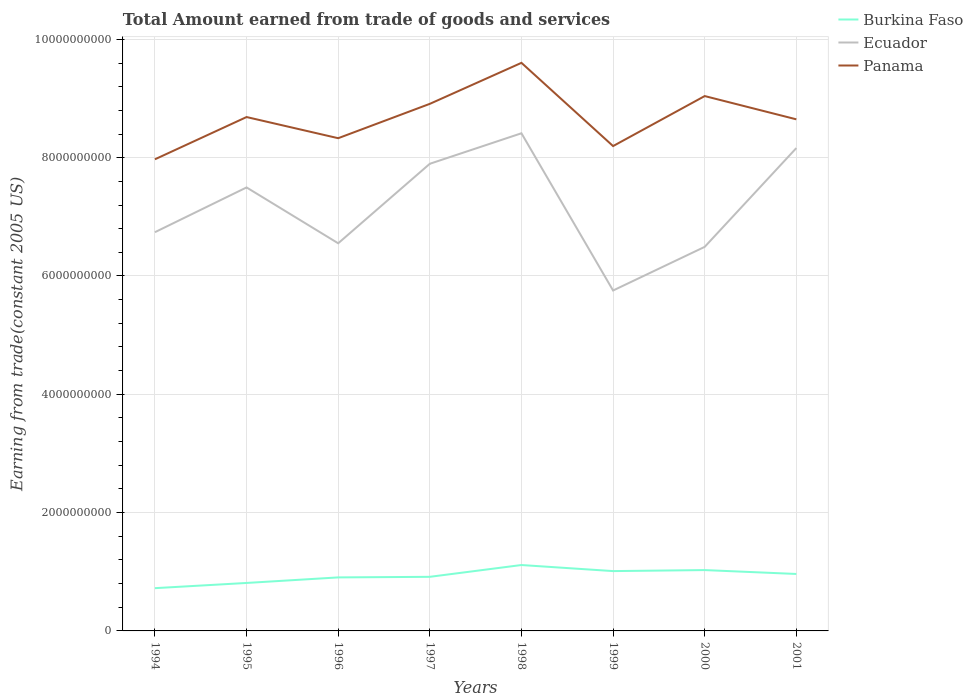Does the line corresponding to Ecuador intersect with the line corresponding to Burkina Faso?
Offer a very short reply. No. Across all years, what is the maximum total amount earned by trading goods and services in Burkina Faso?
Provide a short and direct response. 7.23e+08. In which year was the total amount earned by trading goods and services in Burkina Faso maximum?
Provide a short and direct response. 1994. What is the total total amount earned by trading goods and services in Panama in the graph?
Make the answer very short. -3.55e+08. What is the difference between the highest and the second highest total amount earned by trading goods and services in Ecuador?
Ensure brevity in your answer.  2.66e+09. How many years are there in the graph?
Your answer should be very brief. 8. What is the difference between two consecutive major ticks on the Y-axis?
Your answer should be compact. 2.00e+09. Are the values on the major ticks of Y-axis written in scientific E-notation?
Give a very brief answer. No. Does the graph contain any zero values?
Offer a terse response. No. Where does the legend appear in the graph?
Give a very brief answer. Top right. What is the title of the graph?
Your response must be concise. Total Amount earned from trade of goods and services. What is the label or title of the Y-axis?
Offer a terse response. Earning from trade(constant 2005 US). What is the Earning from trade(constant 2005 US) of Burkina Faso in 1994?
Your response must be concise. 7.23e+08. What is the Earning from trade(constant 2005 US) in Ecuador in 1994?
Your response must be concise. 6.74e+09. What is the Earning from trade(constant 2005 US) of Panama in 1994?
Your answer should be very brief. 7.97e+09. What is the Earning from trade(constant 2005 US) of Burkina Faso in 1995?
Provide a short and direct response. 8.11e+08. What is the Earning from trade(constant 2005 US) of Ecuador in 1995?
Give a very brief answer. 7.50e+09. What is the Earning from trade(constant 2005 US) in Panama in 1995?
Your response must be concise. 8.69e+09. What is the Earning from trade(constant 2005 US) of Burkina Faso in 1996?
Provide a short and direct response. 9.05e+08. What is the Earning from trade(constant 2005 US) of Ecuador in 1996?
Provide a succinct answer. 6.55e+09. What is the Earning from trade(constant 2005 US) in Panama in 1996?
Your response must be concise. 8.33e+09. What is the Earning from trade(constant 2005 US) of Burkina Faso in 1997?
Offer a very short reply. 9.15e+08. What is the Earning from trade(constant 2005 US) of Ecuador in 1997?
Keep it short and to the point. 7.90e+09. What is the Earning from trade(constant 2005 US) in Panama in 1997?
Provide a short and direct response. 8.91e+09. What is the Earning from trade(constant 2005 US) of Burkina Faso in 1998?
Your response must be concise. 1.11e+09. What is the Earning from trade(constant 2005 US) in Ecuador in 1998?
Your response must be concise. 8.41e+09. What is the Earning from trade(constant 2005 US) of Panama in 1998?
Your response must be concise. 9.60e+09. What is the Earning from trade(constant 2005 US) in Burkina Faso in 1999?
Make the answer very short. 1.01e+09. What is the Earning from trade(constant 2005 US) of Ecuador in 1999?
Keep it short and to the point. 5.75e+09. What is the Earning from trade(constant 2005 US) in Panama in 1999?
Your response must be concise. 8.20e+09. What is the Earning from trade(constant 2005 US) of Burkina Faso in 2000?
Offer a very short reply. 1.03e+09. What is the Earning from trade(constant 2005 US) in Ecuador in 2000?
Provide a succinct answer. 6.49e+09. What is the Earning from trade(constant 2005 US) in Panama in 2000?
Your answer should be very brief. 9.04e+09. What is the Earning from trade(constant 2005 US) of Burkina Faso in 2001?
Offer a terse response. 9.63e+08. What is the Earning from trade(constant 2005 US) of Ecuador in 2001?
Your response must be concise. 8.16e+09. What is the Earning from trade(constant 2005 US) of Panama in 2001?
Provide a succinct answer. 8.65e+09. Across all years, what is the maximum Earning from trade(constant 2005 US) in Burkina Faso?
Your response must be concise. 1.11e+09. Across all years, what is the maximum Earning from trade(constant 2005 US) in Ecuador?
Keep it short and to the point. 8.41e+09. Across all years, what is the maximum Earning from trade(constant 2005 US) of Panama?
Your response must be concise. 9.60e+09. Across all years, what is the minimum Earning from trade(constant 2005 US) in Burkina Faso?
Offer a very short reply. 7.23e+08. Across all years, what is the minimum Earning from trade(constant 2005 US) in Ecuador?
Offer a terse response. 5.75e+09. Across all years, what is the minimum Earning from trade(constant 2005 US) of Panama?
Give a very brief answer. 7.97e+09. What is the total Earning from trade(constant 2005 US) of Burkina Faso in the graph?
Make the answer very short. 7.47e+09. What is the total Earning from trade(constant 2005 US) of Ecuador in the graph?
Ensure brevity in your answer.  5.75e+1. What is the total Earning from trade(constant 2005 US) of Panama in the graph?
Your response must be concise. 6.94e+1. What is the difference between the Earning from trade(constant 2005 US) in Burkina Faso in 1994 and that in 1995?
Offer a terse response. -8.80e+07. What is the difference between the Earning from trade(constant 2005 US) in Ecuador in 1994 and that in 1995?
Make the answer very short. -7.57e+08. What is the difference between the Earning from trade(constant 2005 US) of Panama in 1994 and that in 1995?
Ensure brevity in your answer.  -7.14e+08. What is the difference between the Earning from trade(constant 2005 US) of Burkina Faso in 1994 and that in 1996?
Offer a very short reply. -1.82e+08. What is the difference between the Earning from trade(constant 2005 US) of Ecuador in 1994 and that in 1996?
Keep it short and to the point. 1.87e+08. What is the difference between the Earning from trade(constant 2005 US) of Panama in 1994 and that in 1996?
Make the answer very short. -3.57e+08. What is the difference between the Earning from trade(constant 2005 US) of Burkina Faso in 1994 and that in 1997?
Ensure brevity in your answer.  -1.92e+08. What is the difference between the Earning from trade(constant 2005 US) in Ecuador in 1994 and that in 1997?
Your response must be concise. -1.16e+09. What is the difference between the Earning from trade(constant 2005 US) in Panama in 1994 and that in 1997?
Your answer should be compact. -9.37e+08. What is the difference between the Earning from trade(constant 2005 US) in Burkina Faso in 1994 and that in 1998?
Make the answer very short. -3.91e+08. What is the difference between the Earning from trade(constant 2005 US) in Ecuador in 1994 and that in 1998?
Offer a very short reply. -1.67e+09. What is the difference between the Earning from trade(constant 2005 US) of Panama in 1994 and that in 1998?
Your answer should be very brief. -1.63e+09. What is the difference between the Earning from trade(constant 2005 US) in Burkina Faso in 1994 and that in 1999?
Offer a terse response. -2.88e+08. What is the difference between the Earning from trade(constant 2005 US) in Ecuador in 1994 and that in 1999?
Provide a short and direct response. 9.86e+08. What is the difference between the Earning from trade(constant 2005 US) of Panama in 1994 and that in 1999?
Your answer should be compact. -2.24e+08. What is the difference between the Earning from trade(constant 2005 US) in Burkina Faso in 1994 and that in 2000?
Ensure brevity in your answer.  -3.06e+08. What is the difference between the Earning from trade(constant 2005 US) of Ecuador in 1994 and that in 2000?
Your answer should be compact. 2.48e+08. What is the difference between the Earning from trade(constant 2005 US) of Panama in 1994 and that in 2000?
Make the answer very short. -1.07e+09. What is the difference between the Earning from trade(constant 2005 US) of Burkina Faso in 1994 and that in 2001?
Provide a short and direct response. -2.40e+08. What is the difference between the Earning from trade(constant 2005 US) in Ecuador in 1994 and that in 2001?
Keep it short and to the point. -1.42e+09. What is the difference between the Earning from trade(constant 2005 US) of Panama in 1994 and that in 2001?
Provide a short and direct response. -6.76e+08. What is the difference between the Earning from trade(constant 2005 US) in Burkina Faso in 1995 and that in 1996?
Give a very brief answer. -9.37e+07. What is the difference between the Earning from trade(constant 2005 US) of Ecuador in 1995 and that in 1996?
Give a very brief answer. 9.44e+08. What is the difference between the Earning from trade(constant 2005 US) in Panama in 1995 and that in 1996?
Your answer should be very brief. 3.58e+08. What is the difference between the Earning from trade(constant 2005 US) in Burkina Faso in 1995 and that in 1997?
Make the answer very short. -1.04e+08. What is the difference between the Earning from trade(constant 2005 US) of Ecuador in 1995 and that in 1997?
Provide a short and direct response. -4.00e+08. What is the difference between the Earning from trade(constant 2005 US) of Panama in 1995 and that in 1997?
Your answer should be very brief. -2.23e+08. What is the difference between the Earning from trade(constant 2005 US) of Burkina Faso in 1995 and that in 1998?
Ensure brevity in your answer.  -3.03e+08. What is the difference between the Earning from trade(constant 2005 US) of Ecuador in 1995 and that in 1998?
Your answer should be compact. -9.16e+08. What is the difference between the Earning from trade(constant 2005 US) of Panama in 1995 and that in 1998?
Your answer should be very brief. -9.16e+08. What is the difference between the Earning from trade(constant 2005 US) of Burkina Faso in 1995 and that in 1999?
Your answer should be compact. -2.00e+08. What is the difference between the Earning from trade(constant 2005 US) of Ecuador in 1995 and that in 1999?
Your response must be concise. 1.74e+09. What is the difference between the Earning from trade(constant 2005 US) of Panama in 1995 and that in 1999?
Offer a terse response. 4.91e+08. What is the difference between the Earning from trade(constant 2005 US) of Burkina Faso in 1995 and that in 2000?
Offer a very short reply. -2.18e+08. What is the difference between the Earning from trade(constant 2005 US) in Ecuador in 1995 and that in 2000?
Give a very brief answer. 1.00e+09. What is the difference between the Earning from trade(constant 2005 US) in Panama in 1995 and that in 2000?
Keep it short and to the point. -3.55e+08. What is the difference between the Earning from trade(constant 2005 US) in Burkina Faso in 1995 and that in 2001?
Keep it short and to the point. -1.52e+08. What is the difference between the Earning from trade(constant 2005 US) of Ecuador in 1995 and that in 2001?
Your answer should be very brief. -6.65e+08. What is the difference between the Earning from trade(constant 2005 US) of Panama in 1995 and that in 2001?
Your response must be concise. 3.86e+07. What is the difference between the Earning from trade(constant 2005 US) of Burkina Faso in 1996 and that in 1997?
Ensure brevity in your answer.  -9.90e+06. What is the difference between the Earning from trade(constant 2005 US) in Ecuador in 1996 and that in 1997?
Offer a very short reply. -1.34e+09. What is the difference between the Earning from trade(constant 2005 US) in Panama in 1996 and that in 1997?
Ensure brevity in your answer.  -5.81e+08. What is the difference between the Earning from trade(constant 2005 US) of Burkina Faso in 1996 and that in 1998?
Make the answer very short. -2.09e+08. What is the difference between the Earning from trade(constant 2005 US) of Ecuador in 1996 and that in 1998?
Offer a very short reply. -1.86e+09. What is the difference between the Earning from trade(constant 2005 US) in Panama in 1996 and that in 1998?
Keep it short and to the point. -1.27e+09. What is the difference between the Earning from trade(constant 2005 US) of Burkina Faso in 1996 and that in 1999?
Make the answer very short. -1.07e+08. What is the difference between the Earning from trade(constant 2005 US) in Ecuador in 1996 and that in 1999?
Ensure brevity in your answer.  7.98e+08. What is the difference between the Earning from trade(constant 2005 US) of Panama in 1996 and that in 1999?
Ensure brevity in your answer.  1.33e+08. What is the difference between the Earning from trade(constant 2005 US) of Burkina Faso in 1996 and that in 2000?
Your response must be concise. -1.24e+08. What is the difference between the Earning from trade(constant 2005 US) in Ecuador in 1996 and that in 2000?
Offer a very short reply. 6.02e+07. What is the difference between the Earning from trade(constant 2005 US) of Panama in 1996 and that in 2000?
Provide a succinct answer. -7.12e+08. What is the difference between the Earning from trade(constant 2005 US) of Burkina Faso in 1996 and that in 2001?
Provide a short and direct response. -5.82e+07. What is the difference between the Earning from trade(constant 2005 US) of Ecuador in 1996 and that in 2001?
Offer a terse response. -1.61e+09. What is the difference between the Earning from trade(constant 2005 US) of Panama in 1996 and that in 2001?
Offer a very short reply. -3.19e+08. What is the difference between the Earning from trade(constant 2005 US) in Burkina Faso in 1997 and that in 1998?
Offer a very short reply. -1.99e+08. What is the difference between the Earning from trade(constant 2005 US) of Ecuador in 1997 and that in 1998?
Your response must be concise. -5.16e+08. What is the difference between the Earning from trade(constant 2005 US) in Panama in 1997 and that in 1998?
Provide a succinct answer. -6.93e+08. What is the difference between the Earning from trade(constant 2005 US) of Burkina Faso in 1997 and that in 1999?
Offer a terse response. -9.68e+07. What is the difference between the Earning from trade(constant 2005 US) of Ecuador in 1997 and that in 1999?
Give a very brief answer. 2.14e+09. What is the difference between the Earning from trade(constant 2005 US) in Panama in 1997 and that in 1999?
Offer a terse response. 7.14e+08. What is the difference between the Earning from trade(constant 2005 US) in Burkina Faso in 1997 and that in 2000?
Give a very brief answer. -1.14e+08. What is the difference between the Earning from trade(constant 2005 US) of Ecuador in 1997 and that in 2000?
Your response must be concise. 1.40e+09. What is the difference between the Earning from trade(constant 2005 US) in Panama in 1997 and that in 2000?
Offer a terse response. -1.32e+08. What is the difference between the Earning from trade(constant 2005 US) of Burkina Faso in 1997 and that in 2001?
Provide a succinct answer. -4.83e+07. What is the difference between the Earning from trade(constant 2005 US) in Ecuador in 1997 and that in 2001?
Offer a terse response. -2.66e+08. What is the difference between the Earning from trade(constant 2005 US) of Panama in 1997 and that in 2001?
Ensure brevity in your answer.  2.62e+08. What is the difference between the Earning from trade(constant 2005 US) in Burkina Faso in 1998 and that in 1999?
Provide a short and direct response. 1.03e+08. What is the difference between the Earning from trade(constant 2005 US) of Ecuador in 1998 and that in 1999?
Provide a succinct answer. 2.66e+09. What is the difference between the Earning from trade(constant 2005 US) of Panama in 1998 and that in 1999?
Your answer should be very brief. 1.41e+09. What is the difference between the Earning from trade(constant 2005 US) of Burkina Faso in 1998 and that in 2000?
Your response must be concise. 8.54e+07. What is the difference between the Earning from trade(constant 2005 US) of Ecuador in 1998 and that in 2000?
Offer a terse response. 1.92e+09. What is the difference between the Earning from trade(constant 2005 US) in Panama in 1998 and that in 2000?
Your answer should be compact. 5.62e+08. What is the difference between the Earning from trade(constant 2005 US) of Burkina Faso in 1998 and that in 2001?
Ensure brevity in your answer.  1.51e+08. What is the difference between the Earning from trade(constant 2005 US) in Ecuador in 1998 and that in 2001?
Provide a short and direct response. 2.50e+08. What is the difference between the Earning from trade(constant 2005 US) in Panama in 1998 and that in 2001?
Ensure brevity in your answer.  9.55e+08. What is the difference between the Earning from trade(constant 2005 US) of Burkina Faso in 1999 and that in 2000?
Give a very brief answer. -1.71e+07. What is the difference between the Earning from trade(constant 2005 US) of Ecuador in 1999 and that in 2000?
Make the answer very short. -7.38e+08. What is the difference between the Earning from trade(constant 2005 US) of Panama in 1999 and that in 2000?
Keep it short and to the point. -8.45e+08. What is the difference between the Earning from trade(constant 2005 US) of Burkina Faso in 1999 and that in 2001?
Provide a succinct answer. 4.85e+07. What is the difference between the Earning from trade(constant 2005 US) of Ecuador in 1999 and that in 2001?
Your answer should be very brief. -2.41e+09. What is the difference between the Earning from trade(constant 2005 US) in Panama in 1999 and that in 2001?
Your answer should be very brief. -4.52e+08. What is the difference between the Earning from trade(constant 2005 US) of Burkina Faso in 2000 and that in 2001?
Provide a succinct answer. 6.56e+07. What is the difference between the Earning from trade(constant 2005 US) of Ecuador in 2000 and that in 2001?
Offer a very short reply. -1.67e+09. What is the difference between the Earning from trade(constant 2005 US) in Panama in 2000 and that in 2001?
Offer a very short reply. 3.93e+08. What is the difference between the Earning from trade(constant 2005 US) in Burkina Faso in 1994 and the Earning from trade(constant 2005 US) in Ecuador in 1995?
Offer a very short reply. -6.77e+09. What is the difference between the Earning from trade(constant 2005 US) of Burkina Faso in 1994 and the Earning from trade(constant 2005 US) of Panama in 1995?
Your answer should be compact. -7.96e+09. What is the difference between the Earning from trade(constant 2005 US) in Ecuador in 1994 and the Earning from trade(constant 2005 US) in Panama in 1995?
Make the answer very short. -1.95e+09. What is the difference between the Earning from trade(constant 2005 US) of Burkina Faso in 1994 and the Earning from trade(constant 2005 US) of Ecuador in 1996?
Give a very brief answer. -5.83e+09. What is the difference between the Earning from trade(constant 2005 US) in Burkina Faso in 1994 and the Earning from trade(constant 2005 US) in Panama in 1996?
Provide a succinct answer. -7.61e+09. What is the difference between the Earning from trade(constant 2005 US) in Ecuador in 1994 and the Earning from trade(constant 2005 US) in Panama in 1996?
Offer a very short reply. -1.59e+09. What is the difference between the Earning from trade(constant 2005 US) in Burkina Faso in 1994 and the Earning from trade(constant 2005 US) in Ecuador in 1997?
Make the answer very short. -7.17e+09. What is the difference between the Earning from trade(constant 2005 US) in Burkina Faso in 1994 and the Earning from trade(constant 2005 US) in Panama in 1997?
Make the answer very short. -8.19e+09. What is the difference between the Earning from trade(constant 2005 US) of Ecuador in 1994 and the Earning from trade(constant 2005 US) of Panama in 1997?
Provide a succinct answer. -2.17e+09. What is the difference between the Earning from trade(constant 2005 US) in Burkina Faso in 1994 and the Earning from trade(constant 2005 US) in Ecuador in 1998?
Ensure brevity in your answer.  -7.69e+09. What is the difference between the Earning from trade(constant 2005 US) in Burkina Faso in 1994 and the Earning from trade(constant 2005 US) in Panama in 1998?
Your answer should be very brief. -8.88e+09. What is the difference between the Earning from trade(constant 2005 US) in Ecuador in 1994 and the Earning from trade(constant 2005 US) in Panama in 1998?
Your answer should be very brief. -2.86e+09. What is the difference between the Earning from trade(constant 2005 US) in Burkina Faso in 1994 and the Earning from trade(constant 2005 US) in Ecuador in 1999?
Your response must be concise. -5.03e+09. What is the difference between the Earning from trade(constant 2005 US) of Burkina Faso in 1994 and the Earning from trade(constant 2005 US) of Panama in 1999?
Offer a very short reply. -7.47e+09. What is the difference between the Earning from trade(constant 2005 US) of Ecuador in 1994 and the Earning from trade(constant 2005 US) of Panama in 1999?
Provide a short and direct response. -1.46e+09. What is the difference between the Earning from trade(constant 2005 US) of Burkina Faso in 1994 and the Earning from trade(constant 2005 US) of Ecuador in 2000?
Keep it short and to the point. -5.77e+09. What is the difference between the Earning from trade(constant 2005 US) in Burkina Faso in 1994 and the Earning from trade(constant 2005 US) in Panama in 2000?
Your answer should be very brief. -8.32e+09. What is the difference between the Earning from trade(constant 2005 US) of Ecuador in 1994 and the Earning from trade(constant 2005 US) of Panama in 2000?
Provide a short and direct response. -2.30e+09. What is the difference between the Earning from trade(constant 2005 US) in Burkina Faso in 1994 and the Earning from trade(constant 2005 US) in Ecuador in 2001?
Your answer should be very brief. -7.44e+09. What is the difference between the Earning from trade(constant 2005 US) in Burkina Faso in 1994 and the Earning from trade(constant 2005 US) in Panama in 2001?
Your answer should be very brief. -7.93e+09. What is the difference between the Earning from trade(constant 2005 US) of Ecuador in 1994 and the Earning from trade(constant 2005 US) of Panama in 2001?
Provide a succinct answer. -1.91e+09. What is the difference between the Earning from trade(constant 2005 US) of Burkina Faso in 1995 and the Earning from trade(constant 2005 US) of Ecuador in 1996?
Keep it short and to the point. -5.74e+09. What is the difference between the Earning from trade(constant 2005 US) in Burkina Faso in 1995 and the Earning from trade(constant 2005 US) in Panama in 1996?
Make the answer very short. -7.52e+09. What is the difference between the Earning from trade(constant 2005 US) in Ecuador in 1995 and the Earning from trade(constant 2005 US) in Panama in 1996?
Ensure brevity in your answer.  -8.32e+08. What is the difference between the Earning from trade(constant 2005 US) of Burkina Faso in 1995 and the Earning from trade(constant 2005 US) of Ecuador in 1997?
Make the answer very short. -7.09e+09. What is the difference between the Earning from trade(constant 2005 US) in Burkina Faso in 1995 and the Earning from trade(constant 2005 US) in Panama in 1997?
Make the answer very short. -8.10e+09. What is the difference between the Earning from trade(constant 2005 US) of Ecuador in 1995 and the Earning from trade(constant 2005 US) of Panama in 1997?
Ensure brevity in your answer.  -1.41e+09. What is the difference between the Earning from trade(constant 2005 US) in Burkina Faso in 1995 and the Earning from trade(constant 2005 US) in Ecuador in 1998?
Keep it short and to the point. -7.60e+09. What is the difference between the Earning from trade(constant 2005 US) of Burkina Faso in 1995 and the Earning from trade(constant 2005 US) of Panama in 1998?
Your answer should be very brief. -8.79e+09. What is the difference between the Earning from trade(constant 2005 US) in Ecuador in 1995 and the Earning from trade(constant 2005 US) in Panama in 1998?
Provide a succinct answer. -2.11e+09. What is the difference between the Earning from trade(constant 2005 US) of Burkina Faso in 1995 and the Earning from trade(constant 2005 US) of Ecuador in 1999?
Your response must be concise. -4.94e+09. What is the difference between the Earning from trade(constant 2005 US) in Burkina Faso in 1995 and the Earning from trade(constant 2005 US) in Panama in 1999?
Your answer should be compact. -7.39e+09. What is the difference between the Earning from trade(constant 2005 US) in Ecuador in 1995 and the Earning from trade(constant 2005 US) in Panama in 1999?
Provide a succinct answer. -6.99e+08. What is the difference between the Earning from trade(constant 2005 US) in Burkina Faso in 1995 and the Earning from trade(constant 2005 US) in Ecuador in 2000?
Offer a very short reply. -5.68e+09. What is the difference between the Earning from trade(constant 2005 US) of Burkina Faso in 1995 and the Earning from trade(constant 2005 US) of Panama in 2000?
Provide a succinct answer. -8.23e+09. What is the difference between the Earning from trade(constant 2005 US) in Ecuador in 1995 and the Earning from trade(constant 2005 US) in Panama in 2000?
Keep it short and to the point. -1.54e+09. What is the difference between the Earning from trade(constant 2005 US) in Burkina Faso in 1995 and the Earning from trade(constant 2005 US) in Ecuador in 2001?
Keep it short and to the point. -7.35e+09. What is the difference between the Earning from trade(constant 2005 US) of Burkina Faso in 1995 and the Earning from trade(constant 2005 US) of Panama in 2001?
Your answer should be compact. -7.84e+09. What is the difference between the Earning from trade(constant 2005 US) of Ecuador in 1995 and the Earning from trade(constant 2005 US) of Panama in 2001?
Your answer should be compact. -1.15e+09. What is the difference between the Earning from trade(constant 2005 US) of Burkina Faso in 1996 and the Earning from trade(constant 2005 US) of Ecuador in 1997?
Your answer should be compact. -6.99e+09. What is the difference between the Earning from trade(constant 2005 US) in Burkina Faso in 1996 and the Earning from trade(constant 2005 US) in Panama in 1997?
Your response must be concise. -8.01e+09. What is the difference between the Earning from trade(constant 2005 US) of Ecuador in 1996 and the Earning from trade(constant 2005 US) of Panama in 1997?
Your answer should be compact. -2.36e+09. What is the difference between the Earning from trade(constant 2005 US) of Burkina Faso in 1996 and the Earning from trade(constant 2005 US) of Ecuador in 1998?
Provide a short and direct response. -7.51e+09. What is the difference between the Earning from trade(constant 2005 US) of Burkina Faso in 1996 and the Earning from trade(constant 2005 US) of Panama in 1998?
Your response must be concise. -8.70e+09. What is the difference between the Earning from trade(constant 2005 US) of Ecuador in 1996 and the Earning from trade(constant 2005 US) of Panama in 1998?
Offer a very short reply. -3.05e+09. What is the difference between the Earning from trade(constant 2005 US) of Burkina Faso in 1996 and the Earning from trade(constant 2005 US) of Ecuador in 1999?
Provide a short and direct response. -4.85e+09. What is the difference between the Earning from trade(constant 2005 US) in Burkina Faso in 1996 and the Earning from trade(constant 2005 US) in Panama in 1999?
Your answer should be very brief. -7.29e+09. What is the difference between the Earning from trade(constant 2005 US) of Ecuador in 1996 and the Earning from trade(constant 2005 US) of Panama in 1999?
Ensure brevity in your answer.  -1.64e+09. What is the difference between the Earning from trade(constant 2005 US) in Burkina Faso in 1996 and the Earning from trade(constant 2005 US) in Ecuador in 2000?
Keep it short and to the point. -5.59e+09. What is the difference between the Earning from trade(constant 2005 US) of Burkina Faso in 1996 and the Earning from trade(constant 2005 US) of Panama in 2000?
Provide a short and direct response. -8.14e+09. What is the difference between the Earning from trade(constant 2005 US) of Ecuador in 1996 and the Earning from trade(constant 2005 US) of Panama in 2000?
Offer a terse response. -2.49e+09. What is the difference between the Earning from trade(constant 2005 US) in Burkina Faso in 1996 and the Earning from trade(constant 2005 US) in Ecuador in 2001?
Ensure brevity in your answer.  -7.26e+09. What is the difference between the Earning from trade(constant 2005 US) in Burkina Faso in 1996 and the Earning from trade(constant 2005 US) in Panama in 2001?
Your answer should be very brief. -7.74e+09. What is the difference between the Earning from trade(constant 2005 US) in Ecuador in 1996 and the Earning from trade(constant 2005 US) in Panama in 2001?
Ensure brevity in your answer.  -2.10e+09. What is the difference between the Earning from trade(constant 2005 US) in Burkina Faso in 1997 and the Earning from trade(constant 2005 US) in Ecuador in 1998?
Offer a terse response. -7.50e+09. What is the difference between the Earning from trade(constant 2005 US) of Burkina Faso in 1997 and the Earning from trade(constant 2005 US) of Panama in 1998?
Keep it short and to the point. -8.69e+09. What is the difference between the Earning from trade(constant 2005 US) of Ecuador in 1997 and the Earning from trade(constant 2005 US) of Panama in 1998?
Offer a terse response. -1.71e+09. What is the difference between the Earning from trade(constant 2005 US) of Burkina Faso in 1997 and the Earning from trade(constant 2005 US) of Ecuador in 1999?
Make the answer very short. -4.84e+09. What is the difference between the Earning from trade(constant 2005 US) in Burkina Faso in 1997 and the Earning from trade(constant 2005 US) in Panama in 1999?
Ensure brevity in your answer.  -7.28e+09. What is the difference between the Earning from trade(constant 2005 US) in Ecuador in 1997 and the Earning from trade(constant 2005 US) in Panama in 1999?
Provide a short and direct response. -2.99e+08. What is the difference between the Earning from trade(constant 2005 US) in Burkina Faso in 1997 and the Earning from trade(constant 2005 US) in Ecuador in 2000?
Your answer should be very brief. -5.58e+09. What is the difference between the Earning from trade(constant 2005 US) of Burkina Faso in 1997 and the Earning from trade(constant 2005 US) of Panama in 2000?
Offer a very short reply. -8.13e+09. What is the difference between the Earning from trade(constant 2005 US) of Ecuador in 1997 and the Earning from trade(constant 2005 US) of Panama in 2000?
Your answer should be very brief. -1.14e+09. What is the difference between the Earning from trade(constant 2005 US) of Burkina Faso in 1997 and the Earning from trade(constant 2005 US) of Ecuador in 2001?
Offer a terse response. -7.25e+09. What is the difference between the Earning from trade(constant 2005 US) of Burkina Faso in 1997 and the Earning from trade(constant 2005 US) of Panama in 2001?
Provide a succinct answer. -7.73e+09. What is the difference between the Earning from trade(constant 2005 US) in Ecuador in 1997 and the Earning from trade(constant 2005 US) in Panama in 2001?
Provide a succinct answer. -7.51e+08. What is the difference between the Earning from trade(constant 2005 US) in Burkina Faso in 1998 and the Earning from trade(constant 2005 US) in Ecuador in 1999?
Offer a terse response. -4.64e+09. What is the difference between the Earning from trade(constant 2005 US) in Burkina Faso in 1998 and the Earning from trade(constant 2005 US) in Panama in 1999?
Offer a terse response. -7.08e+09. What is the difference between the Earning from trade(constant 2005 US) in Ecuador in 1998 and the Earning from trade(constant 2005 US) in Panama in 1999?
Provide a succinct answer. 2.17e+08. What is the difference between the Earning from trade(constant 2005 US) of Burkina Faso in 1998 and the Earning from trade(constant 2005 US) of Ecuador in 2000?
Your answer should be compact. -5.38e+09. What is the difference between the Earning from trade(constant 2005 US) of Burkina Faso in 1998 and the Earning from trade(constant 2005 US) of Panama in 2000?
Keep it short and to the point. -7.93e+09. What is the difference between the Earning from trade(constant 2005 US) in Ecuador in 1998 and the Earning from trade(constant 2005 US) in Panama in 2000?
Provide a short and direct response. -6.29e+08. What is the difference between the Earning from trade(constant 2005 US) in Burkina Faso in 1998 and the Earning from trade(constant 2005 US) in Ecuador in 2001?
Make the answer very short. -7.05e+09. What is the difference between the Earning from trade(constant 2005 US) of Burkina Faso in 1998 and the Earning from trade(constant 2005 US) of Panama in 2001?
Your response must be concise. -7.53e+09. What is the difference between the Earning from trade(constant 2005 US) of Ecuador in 1998 and the Earning from trade(constant 2005 US) of Panama in 2001?
Make the answer very short. -2.36e+08. What is the difference between the Earning from trade(constant 2005 US) in Burkina Faso in 1999 and the Earning from trade(constant 2005 US) in Ecuador in 2000?
Provide a succinct answer. -5.48e+09. What is the difference between the Earning from trade(constant 2005 US) in Burkina Faso in 1999 and the Earning from trade(constant 2005 US) in Panama in 2000?
Offer a very short reply. -8.03e+09. What is the difference between the Earning from trade(constant 2005 US) in Ecuador in 1999 and the Earning from trade(constant 2005 US) in Panama in 2000?
Provide a succinct answer. -3.29e+09. What is the difference between the Earning from trade(constant 2005 US) in Burkina Faso in 1999 and the Earning from trade(constant 2005 US) in Ecuador in 2001?
Offer a terse response. -7.15e+09. What is the difference between the Earning from trade(constant 2005 US) of Burkina Faso in 1999 and the Earning from trade(constant 2005 US) of Panama in 2001?
Ensure brevity in your answer.  -7.64e+09. What is the difference between the Earning from trade(constant 2005 US) in Ecuador in 1999 and the Earning from trade(constant 2005 US) in Panama in 2001?
Provide a succinct answer. -2.89e+09. What is the difference between the Earning from trade(constant 2005 US) of Burkina Faso in 2000 and the Earning from trade(constant 2005 US) of Ecuador in 2001?
Make the answer very short. -7.13e+09. What is the difference between the Earning from trade(constant 2005 US) in Burkina Faso in 2000 and the Earning from trade(constant 2005 US) in Panama in 2001?
Offer a very short reply. -7.62e+09. What is the difference between the Earning from trade(constant 2005 US) in Ecuador in 2000 and the Earning from trade(constant 2005 US) in Panama in 2001?
Your response must be concise. -2.16e+09. What is the average Earning from trade(constant 2005 US) of Burkina Faso per year?
Provide a short and direct response. 9.34e+08. What is the average Earning from trade(constant 2005 US) of Ecuador per year?
Provide a short and direct response. 7.19e+09. What is the average Earning from trade(constant 2005 US) of Panama per year?
Your answer should be compact. 8.67e+09. In the year 1994, what is the difference between the Earning from trade(constant 2005 US) in Burkina Faso and Earning from trade(constant 2005 US) in Ecuador?
Offer a very short reply. -6.02e+09. In the year 1994, what is the difference between the Earning from trade(constant 2005 US) in Burkina Faso and Earning from trade(constant 2005 US) in Panama?
Provide a short and direct response. -7.25e+09. In the year 1994, what is the difference between the Earning from trade(constant 2005 US) in Ecuador and Earning from trade(constant 2005 US) in Panama?
Ensure brevity in your answer.  -1.23e+09. In the year 1995, what is the difference between the Earning from trade(constant 2005 US) of Burkina Faso and Earning from trade(constant 2005 US) of Ecuador?
Provide a succinct answer. -6.69e+09. In the year 1995, what is the difference between the Earning from trade(constant 2005 US) of Burkina Faso and Earning from trade(constant 2005 US) of Panama?
Provide a succinct answer. -7.88e+09. In the year 1995, what is the difference between the Earning from trade(constant 2005 US) in Ecuador and Earning from trade(constant 2005 US) in Panama?
Your answer should be compact. -1.19e+09. In the year 1996, what is the difference between the Earning from trade(constant 2005 US) in Burkina Faso and Earning from trade(constant 2005 US) in Ecuador?
Your answer should be compact. -5.65e+09. In the year 1996, what is the difference between the Earning from trade(constant 2005 US) of Burkina Faso and Earning from trade(constant 2005 US) of Panama?
Give a very brief answer. -7.42e+09. In the year 1996, what is the difference between the Earning from trade(constant 2005 US) of Ecuador and Earning from trade(constant 2005 US) of Panama?
Your answer should be very brief. -1.78e+09. In the year 1997, what is the difference between the Earning from trade(constant 2005 US) in Burkina Faso and Earning from trade(constant 2005 US) in Ecuador?
Offer a terse response. -6.98e+09. In the year 1997, what is the difference between the Earning from trade(constant 2005 US) in Burkina Faso and Earning from trade(constant 2005 US) in Panama?
Ensure brevity in your answer.  -8.00e+09. In the year 1997, what is the difference between the Earning from trade(constant 2005 US) in Ecuador and Earning from trade(constant 2005 US) in Panama?
Offer a very short reply. -1.01e+09. In the year 1998, what is the difference between the Earning from trade(constant 2005 US) in Burkina Faso and Earning from trade(constant 2005 US) in Ecuador?
Provide a short and direct response. -7.30e+09. In the year 1998, what is the difference between the Earning from trade(constant 2005 US) in Burkina Faso and Earning from trade(constant 2005 US) in Panama?
Ensure brevity in your answer.  -8.49e+09. In the year 1998, what is the difference between the Earning from trade(constant 2005 US) in Ecuador and Earning from trade(constant 2005 US) in Panama?
Ensure brevity in your answer.  -1.19e+09. In the year 1999, what is the difference between the Earning from trade(constant 2005 US) of Burkina Faso and Earning from trade(constant 2005 US) of Ecuador?
Provide a short and direct response. -4.74e+09. In the year 1999, what is the difference between the Earning from trade(constant 2005 US) of Burkina Faso and Earning from trade(constant 2005 US) of Panama?
Ensure brevity in your answer.  -7.18e+09. In the year 1999, what is the difference between the Earning from trade(constant 2005 US) of Ecuador and Earning from trade(constant 2005 US) of Panama?
Your answer should be very brief. -2.44e+09. In the year 2000, what is the difference between the Earning from trade(constant 2005 US) of Burkina Faso and Earning from trade(constant 2005 US) of Ecuador?
Offer a terse response. -5.46e+09. In the year 2000, what is the difference between the Earning from trade(constant 2005 US) of Burkina Faso and Earning from trade(constant 2005 US) of Panama?
Your response must be concise. -8.01e+09. In the year 2000, what is the difference between the Earning from trade(constant 2005 US) of Ecuador and Earning from trade(constant 2005 US) of Panama?
Give a very brief answer. -2.55e+09. In the year 2001, what is the difference between the Earning from trade(constant 2005 US) of Burkina Faso and Earning from trade(constant 2005 US) of Ecuador?
Keep it short and to the point. -7.20e+09. In the year 2001, what is the difference between the Earning from trade(constant 2005 US) of Burkina Faso and Earning from trade(constant 2005 US) of Panama?
Give a very brief answer. -7.69e+09. In the year 2001, what is the difference between the Earning from trade(constant 2005 US) in Ecuador and Earning from trade(constant 2005 US) in Panama?
Keep it short and to the point. -4.86e+08. What is the ratio of the Earning from trade(constant 2005 US) in Burkina Faso in 1994 to that in 1995?
Offer a terse response. 0.89. What is the ratio of the Earning from trade(constant 2005 US) of Ecuador in 1994 to that in 1995?
Ensure brevity in your answer.  0.9. What is the ratio of the Earning from trade(constant 2005 US) in Panama in 1994 to that in 1995?
Keep it short and to the point. 0.92. What is the ratio of the Earning from trade(constant 2005 US) in Burkina Faso in 1994 to that in 1996?
Offer a terse response. 0.8. What is the ratio of the Earning from trade(constant 2005 US) in Ecuador in 1994 to that in 1996?
Your answer should be compact. 1.03. What is the ratio of the Earning from trade(constant 2005 US) in Panama in 1994 to that in 1996?
Your answer should be very brief. 0.96. What is the ratio of the Earning from trade(constant 2005 US) of Burkina Faso in 1994 to that in 1997?
Your answer should be very brief. 0.79. What is the ratio of the Earning from trade(constant 2005 US) of Ecuador in 1994 to that in 1997?
Provide a short and direct response. 0.85. What is the ratio of the Earning from trade(constant 2005 US) of Panama in 1994 to that in 1997?
Make the answer very short. 0.89. What is the ratio of the Earning from trade(constant 2005 US) of Burkina Faso in 1994 to that in 1998?
Provide a succinct answer. 0.65. What is the ratio of the Earning from trade(constant 2005 US) of Ecuador in 1994 to that in 1998?
Your answer should be very brief. 0.8. What is the ratio of the Earning from trade(constant 2005 US) of Panama in 1994 to that in 1998?
Keep it short and to the point. 0.83. What is the ratio of the Earning from trade(constant 2005 US) in Burkina Faso in 1994 to that in 1999?
Your answer should be very brief. 0.71. What is the ratio of the Earning from trade(constant 2005 US) in Ecuador in 1994 to that in 1999?
Keep it short and to the point. 1.17. What is the ratio of the Earning from trade(constant 2005 US) in Panama in 1994 to that in 1999?
Your response must be concise. 0.97. What is the ratio of the Earning from trade(constant 2005 US) of Burkina Faso in 1994 to that in 2000?
Provide a short and direct response. 0.7. What is the ratio of the Earning from trade(constant 2005 US) in Ecuador in 1994 to that in 2000?
Give a very brief answer. 1.04. What is the ratio of the Earning from trade(constant 2005 US) of Panama in 1994 to that in 2000?
Keep it short and to the point. 0.88. What is the ratio of the Earning from trade(constant 2005 US) of Burkina Faso in 1994 to that in 2001?
Offer a terse response. 0.75. What is the ratio of the Earning from trade(constant 2005 US) of Ecuador in 1994 to that in 2001?
Your response must be concise. 0.83. What is the ratio of the Earning from trade(constant 2005 US) of Panama in 1994 to that in 2001?
Offer a very short reply. 0.92. What is the ratio of the Earning from trade(constant 2005 US) of Burkina Faso in 1995 to that in 1996?
Your response must be concise. 0.9. What is the ratio of the Earning from trade(constant 2005 US) of Ecuador in 1995 to that in 1996?
Ensure brevity in your answer.  1.14. What is the ratio of the Earning from trade(constant 2005 US) in Panama in 1995 to that in 1996?
Ensure brevity in your answer.  1.04. What is the ratio of the Earning from trade(constant 2005 US) in Burkina Faso in 1995 to that in 1997?
Give a very brief answer. 0.89. What is the ratio of the Earning from trade(constant 2005 US) of Ecuador in 1995 to that in 1997?
Offer a terse response. 0.95. What is the ratio of the Earning from trade(constant 2005 US) of Burkina Faso in 1995 to that in 1998?
Make the answer very short. 0.73. What is the ratio of the Earning from trade(constant 2005 US) in Ecuador in 1995 to that in 1998?
Ensure brevity in your answer.  0.89. What is the ratio of the Earning from trade(constant 2005 US) of Panama in 1995 to that in 1998?
Offer a very short reply. 0.9. What is the ratio of the Earning from trade(constant 2005 US) in Burkina Faso in 1995 to that in 1999?
Make the answer very short. 0.8. What is the ratio of the Earning from trade(constant 2005 US) of Ecuador in 1995 to that in 1999?
Provide a succinct answer. 1.3. What is the ratio of the Earning from trade(constant 2005 US) of Panama in 1995 to that in 1999?
Offer a very short reply. 1.06. What is the ratio of the Earning from trade(constant 2005 US) of Burkina Faso in 1995 to that in 2000?
Ensure brevity in your answer.  0.79. What is the ratio of the Earning from trade(constant 2005 US) in Ecuador in 1995 to that in 2000?
Offer a terse response. 1.15. What is the ratio of the Earning from trade(constant 2005 US) in Panama in 1995 to that in 2000?
Offer a very short reply. 0.96. What is the ratio of the Earning from trade(constant 2005 US) in Burkina Faso in 1995 to that in 2001?
Give a very brief answer. 0.84. What is the ratio of the Earning from trade(constant 2005 US) in Ecuador in 1995 to that in 2001?
Offer a terse response. 0.92. What is the ratio of the Earning from trade(constant 2005 US) in Panama in 1995 to that in 2001?
Ensure brevity in your answer.  1. What is the ratio of the Earning from trade(constant 2005 US) in Burkina Faso in 1996 to that in 1997?
Your answer should be compact. 0.99. What is the ratio of the Earning from trade(constant 2005 US) in Ecuador in 1996 to that in 1997?
Offer a very short reply. 0.83. What is the ratio of the Earning from trade(constant 2005 US) in Panama in 1996 to that in 1997?
Provide a succinct answer. 0.93. What is the ratio of the Earning from trade(constant 2005 US) of Burkina Faso in 1996 to that in 1998?
Provide a succinct answer. 0.81. What is the ratio of the Earning from trade(constant 2005 US) of Ecuador in 1996 to that in 1998?
Keep it short and to the point. 0.78. What is the ratio of the Earning from trade(constant 2005 US) of Panama in 1996 to that in 1998?
Your answer should be very brief. 0.87. What is the ratio of the Earning from trade(constant 2005 US) in Burkina Faso in 1996 to that in 1999?
Provide a short and direct response. 0.89. What is the ratio of the Earning from trade(constant 2005 US) of Ecuador in 1996 to that in 1999?
Your response must be concise. 1.14. What is the ratio of the Earning from trade(constant 2005 US) in Panama in 1996 to that in 1999?
Keep it short and to the point. 1.02. What is the ratio of the Earning from trade(constant 2005 US) of Burkina Faso in 1996 to that in 2000?
Make the answer very short. 0.88. What is the ratio of the Earning from trade(constant 2005 US) in Ecuador in 1996 to that in 2000?
Give a very brief answer. 1.01. What is the ratio of the Earning from trade(constant 2005 US) of Panama in 1996 to that in 2000?
Your answer should be compact. 0.92. What is the ratio of the Earning from trade(constant 2005 US) of Burkina Faso in 1996 to that in 2001?
Make the answer very short. 0.94. What is the ratio of the Earning from trade(constant 2005 US) in Ecuador in 1996 to that in 2001?
Your response must be concise. 0.8. What is the ratio of the Earning from trade(constant 2005 US) in Panama in 1996 to that in 2001?
Make the answer very short. 0.96. What is the ratio of the Earning from trade(constant 2005 US) in Burkina Faso in 1997 to that in 1998?
Make the answer very short. 0.82. What is the ratio of the Earning from trade(constant 2005 US) of Ecuador in 1997 to that in 1998?
Give a very brief answer. 0.94. What is the ratio of the Earning from trade(constant 2005 US) in Panama in 1997 to that in 1998?
Make the answer very short. 0.93. What is the ratio of the Earning from trade(constant 2005 US) of Burkina Faso in 1997 to that in 1999?
Offer a very short reply. 0.9. What is the ratio of the Earning from trade(constant 2005 US) of Ecuador in 1997 to that in 1999?
Keep it short and to the point. 1.37. What is the ratio of the Earning from trade(constant 2005 US) of Panama in 1997 to that in 1999?
Keep it short and to the point. 1.09. What is the ratio of the Earning from trade(constant 2005 US) in Burkina Faso in 1997 to that in 2000?
Offer a very short reply. 0.89. What is the ratio of the Earning from trade(constant 2005 US) of Ecuador in 1997 to that in 2000?
Make the answer very short. 1.22. What is the ratio of the Earning from trade(constant 2005 US) in Panama in 1997 to that in 2000?
Your answer should be compact. 0.99. What is the ratio of the Earning from trade(constant 2005 US) of Burkina Faso in 1997 to that in 2001?
Your answer should be compact. 0.95. What is the ratio of the Earning from trade(constant 2005 US) of Ecuador in 1997 to that in 2001?
Your response must be concise. 0.97. What is the ratio of the Earning from trade(constant 2005 US) of Panama in 1997 to that in 2001?
Your response must be concise. 1.03. What is the ratio of the Earning from trade(constant 2005 US) in Burkina Faso in 1998 to that in 1999?
Your response must be concise. 1.1. What is the ratio of the Earning from trade(constant 2005 US) in Ecuador in 1998 to that in 1999?
Provide a succinct answer. 1.46. What is the ratio of the Earning from trade(constant 2005 US) in Panama in 1998 to that in 1999?
Your answer should be very brief. 1.17. What is the ratio of the Earning from trade(constant 2005 US) in Burkina Faso in 1998 to that in 2000?
Ensure brevity in your answer.  1.08. What is the ratio of the Earning from trade(constant 2005 US) in Ecuador in 1998 to that in 2000?
Provide a succinct answer. 1.3. What is the ratio of the Earning from trade(constant 2005 US) in Panama in 1998 to that in 2000?
Your answer should be very brief. 1.06. What is the ratio of the Earning from trade(constant 2005 US) of Burkina Faso in 1998 to that in 2001?
Your answer should be compact. 1.16. What is the ratio of the Earning from trade(constant 2005 US) of Ecuador in 1998 to that in 2001?
Provide a succinct answer. 1.03. What is the ratio of the Earning from trade(constant 2005 US) of Panama in 1998 to that in 2001?
Ensure brevity in your answer.  1.11. What is the ratio of the Earning from trade(constant 2005 US) of Burkina Faso in 1999 to that in 2000?
Offer a terse response. 0.98. What is the ratio of the Earning from trade(constant 2005 US) of Ecuador in 1999 to that in 2000?
Provide a short and direct response. 0.89. What is the ratio of the Earning from trade(constant 2005 US) of Panama in 1999 to that in 2000?
Make the answer very short. 0.91. What is the ratio of the Earning from trade(constant 2005 US) in Burkina Faso in 1999 to that in 2001?
Offer a terse response. 1.05. What is the ratio of the Earning from trade(constant 2005 US) of Ecuador in 1999 to that in 2001?
Offer a very short reply. 0.7. What is the ratio of the Earning from trade(constant 2005 US) of Panama in 1999 to that in 2001?
Ensure brevity in your answer.  0.95. What is the ratio of the Earning from trade(constant 2005 US) of Burkina Faso in 2000 to that in 2001?
Your answer should be compact. 1.07. What is the ratio of the Earning from trade(constant 2005 US) in Ecuador in 2000 to that in 2001?
Your answer should be very brief. 0.8. What is the ratio of the Earning from trade(constant 2005 US) in Panama in 2000 to that in 2001?
Provide a succinct answer. 1.05. What is the difference between the highest and the second highest Earning from trade(constant 2005 US) in Burkina Faso?
Provide a succinct answer. 8.54e+07. What is the difference between the highest and the second highest Earning from trade(constant 2005 US) of Ecuador?
Provide a short and direct response. 2.50e+08. What is the difference between the highest and the second highest Earning from trade(constant 2005 US) of Panama?
Offer a terse response. 5.62e+08. What is the difference between the highest and the lowest Earning from trade(constant 2005 US) of Burkina Faso?
Your response must be concise. 3.91e+08. What is the difference between the highest and the lowest Earning from trade(constant 2005 US) of Ecuador?
Offer a very short reply. 2.66e+09. What is the difference between the highest and the lowest Earning from trade(constant 2005 US) of Panama?
Your answer should be very brief. 1.63e+09. 